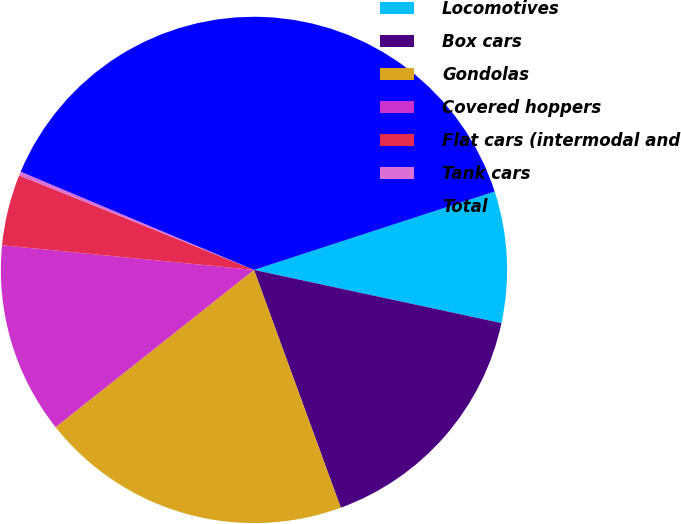Convert chart. <chart><loc_0><loc_0><loc_500><loc_500><pie_chart><fcel>Locomotives<fcel>Box cars<fcel>Gondolas<fcel>Covered hoppers<fcel>Flat cars (intermodal and<fcel>Tank cars<fcel>Total<nl><fcel>8.38%<fcel>16.06%<fcel>19.9%<fcel>12.22%<fcel>4.54%<fcel>0.25%<fcel>38.64%<nl></chart> 